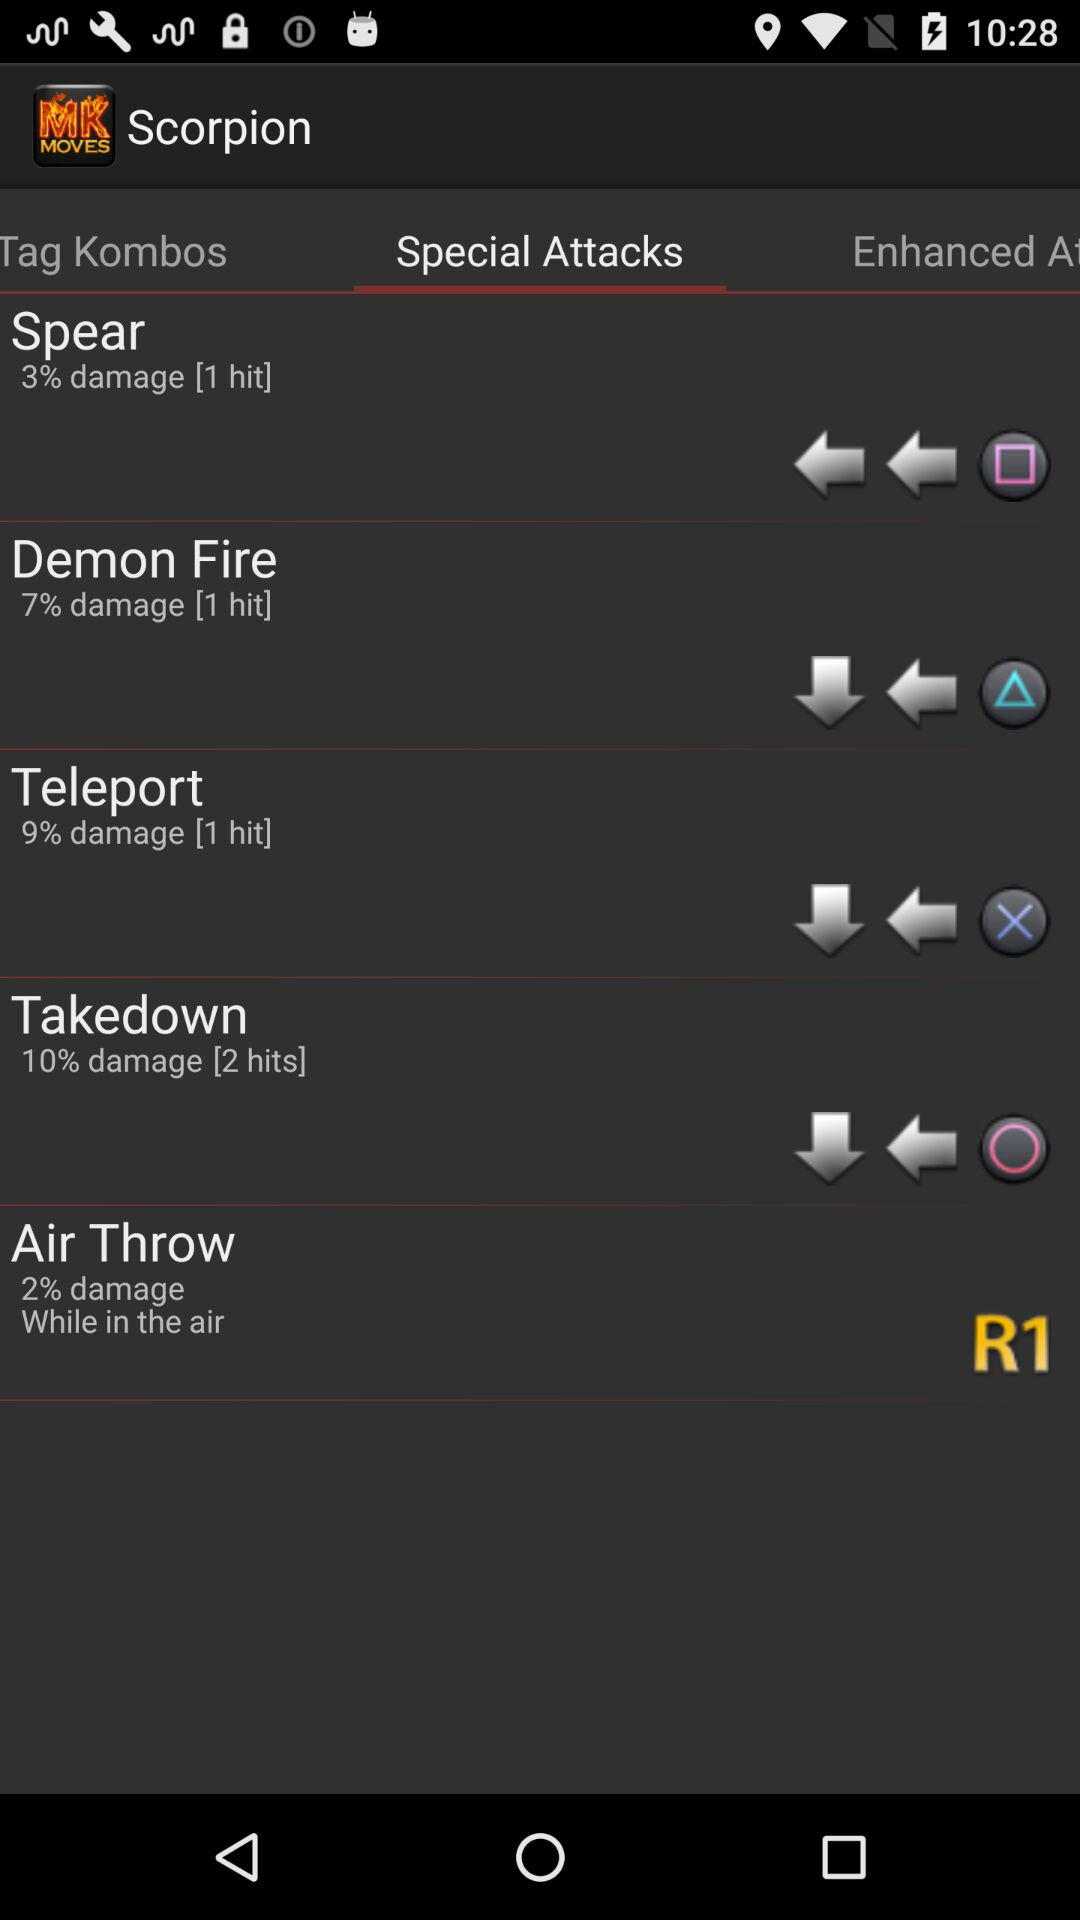What is the number of hits made on the spear? The number of hits made on the spear is 1. 